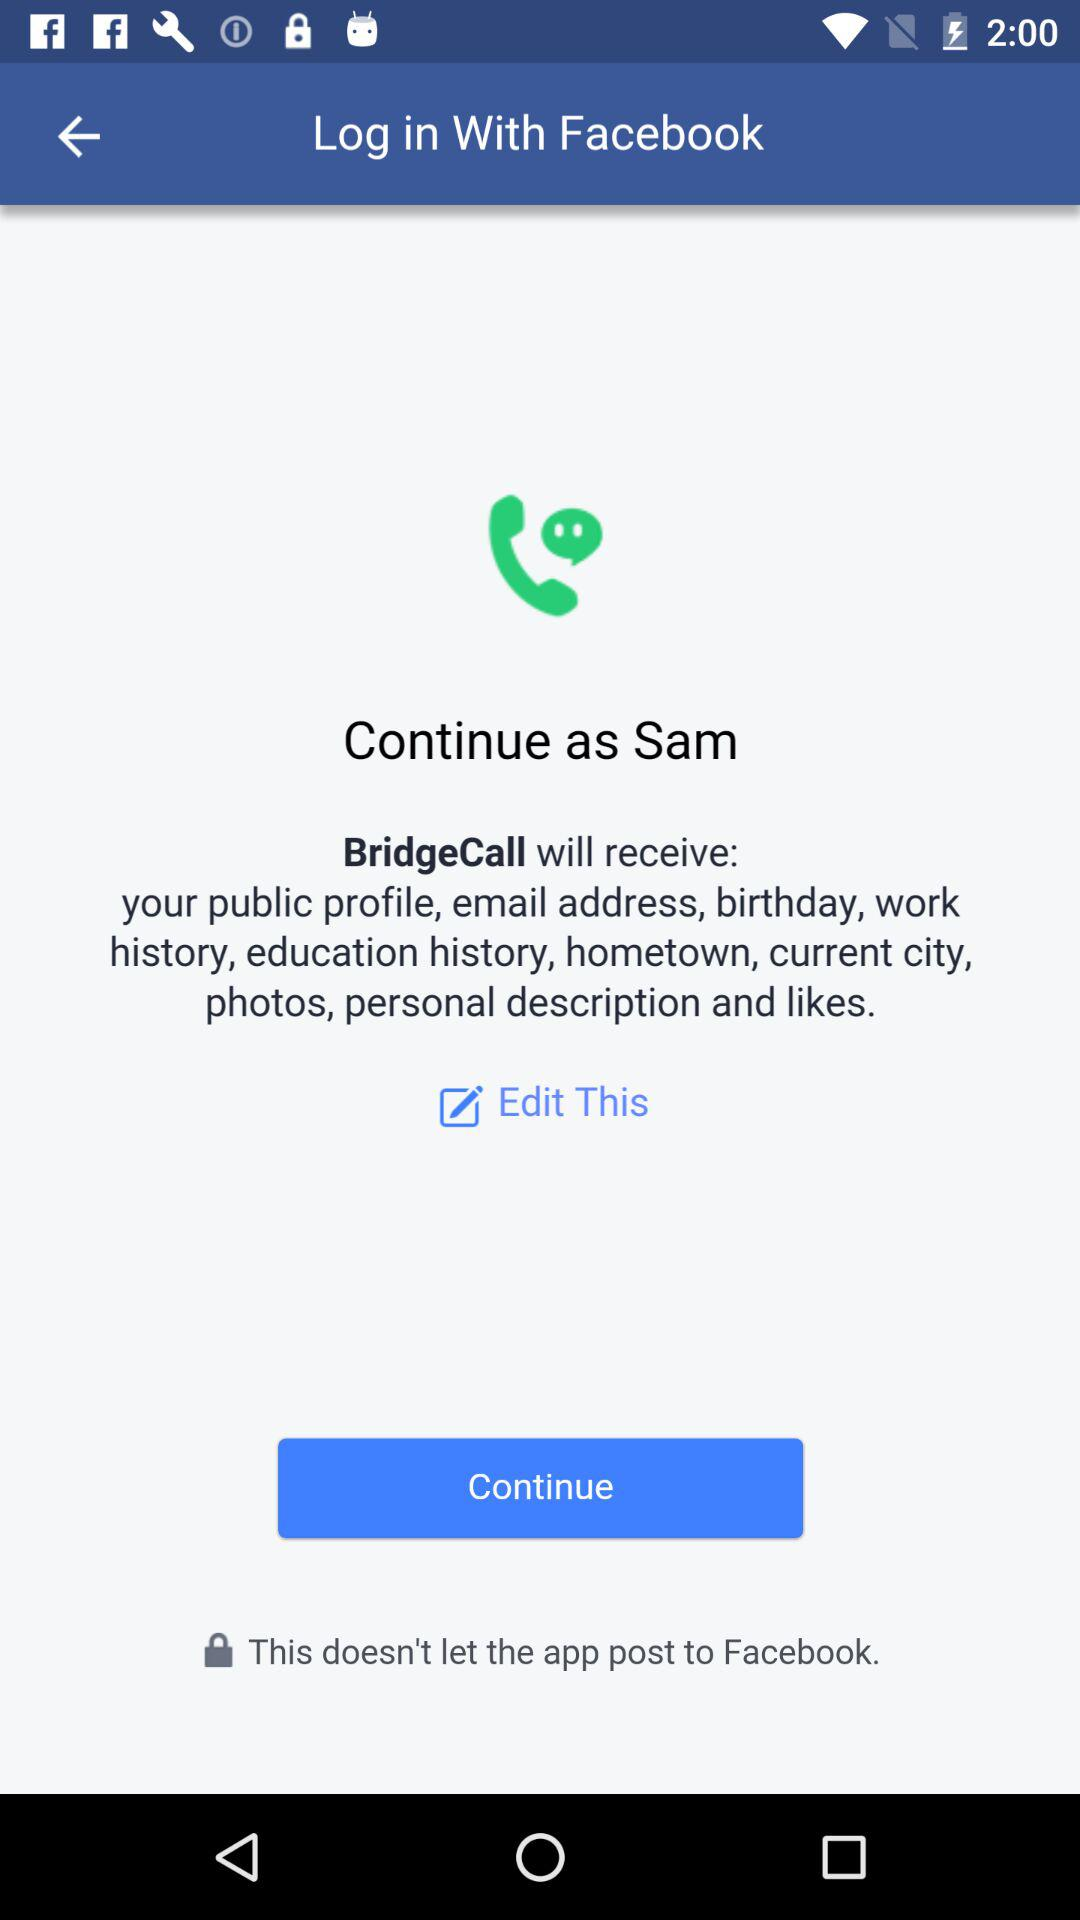What application is asking for permission? The application is "BridgeCall". 